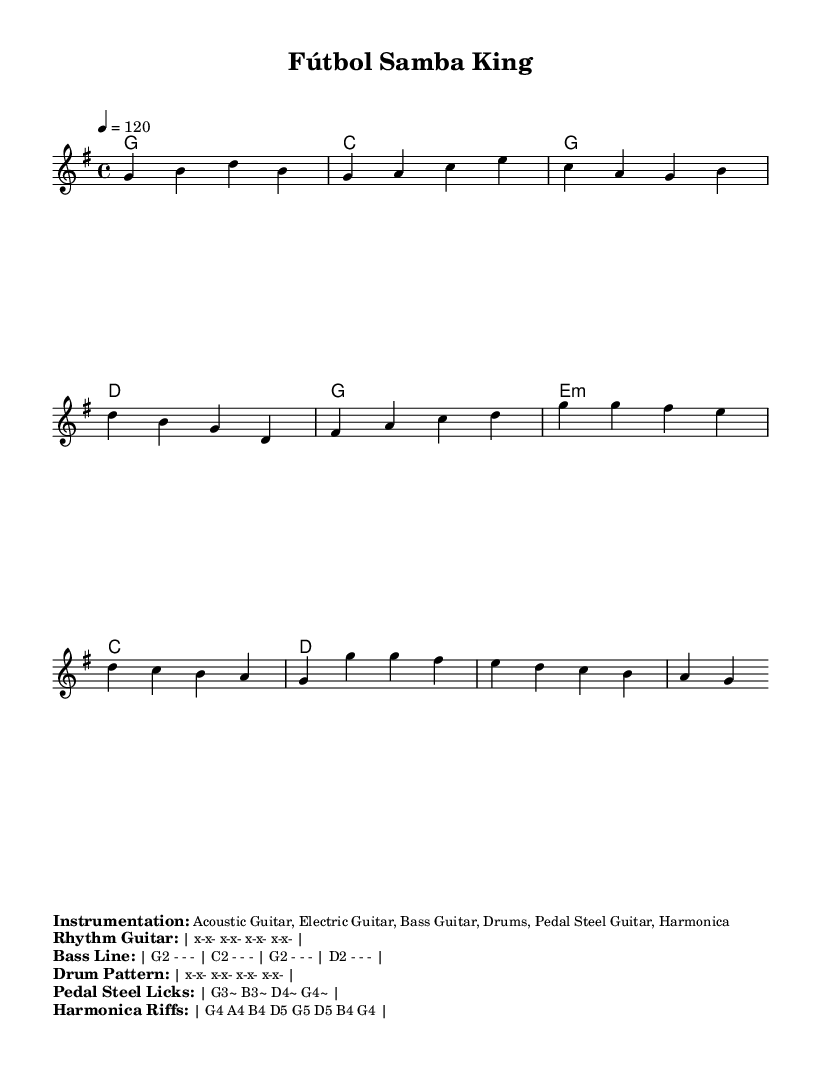What is the key signature of this music? The key signature indicated is G major, which has one sharp (F#). You can find the key signature at the beginning of the sheet music next to the clef.
Answer: G major What is the time signature of this music? The time signature shown is 4/4, which means there are four beats in each measure and the quarter note gets one beat. This is also displayed at the beginning of the sheet music.
Answer: 4/4 What is the tempo marking of this music? The tempo marking of the piece is indicated as quarter note equals 120, meaning it should be played at a moderate speed of 120 beats per minute. This is shown at the start of the section containing tempo instructions.
Answer: 120 What is the main theme of the lyrics? The lyrics celebrate a soccer legend, highlighting their skills and enduring legacy in the sport. The first verse references a journey from the streets to the global stage, depicting the admiration for their talent.
Answer: Soccer legend How many measures are in the verse? The verse consists of four measures as indicated by the structure of the melody and the position of the bar lines. Counting the measures of the verse section directly provides the answer.
Answer: 4 What instruments are indicated in the instrumentation? The instruments listed include Acoustic Guitar, Electric Guitar, Bass Guitar, Drums, Pedal Steel Guitar, and Harmonica. This information is found in the marked section detailing the instrumentation.
Answer: Acoustic Guitar, Electric Guitar, Bass Guitar, Drums, Pedal Steel Guitar, Harmonica What is the harmonic progression in the chorus? The harmonic progression for the chorus is G, E minor, C, D as shown in the harmony section. You can identify the chords written in the chord mode that correspond to the chorus lyrics.
Answer: G, E minor, C, D 